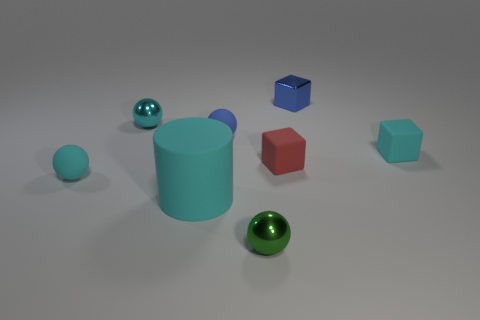What material is the tiny cube that is the same color as the matte cylinder?
Your answer should be very brief. Rubber. The tiny metal thing on the right side of the tiny green object is what color?
Keep it short and to the point. Blue. Do the metallic block and the rubber cylinder have the same color?
Keep it short and to the point. No. How many red rubber cubes are behind the cyan ball behind the cyan rubber thing that is right of the blue metal object?
Your answer should be very brief. 0. What is the size of the blue cube?
Provide a succinct answer. Small. There is a blue sphere that is the same size as the cyan matte sphere; what material is it?
Your response must be concise. Rubber. There is a cyan cylinder; what number of small spheres are on the left side of it?
Offer a very short reply. 2. Are the small block behind the blue rubber thing and the small cyan thing that is behind the cyan rubber block made of the same material?
Give a very brief answer. Yes. What shape is the small cyan matte object that is to the right of the small metal object to the right of the object in front of the large cyan rubber object?
Your response must be concise. Cube. The big cyan object has what shape?
Keep it short and to the point. Cylinder. 